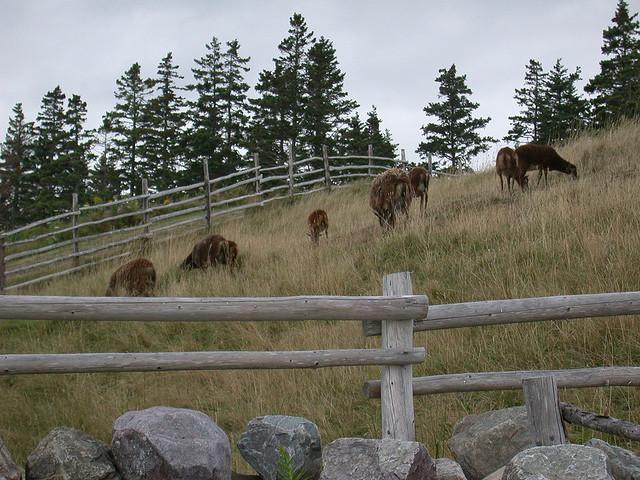Are all the animals adults?
Concise answer only. No. Are those trees at the back?
Keep it brief. Yes. What kind of animal is this?
Give a very brief answer. Cow. What kind of animal is shown?
Be succinct. Cow. 